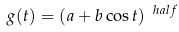<formula> <loc_0><loc_0><loc_500><loc_500>g ( t ) = ( a + b \cos t ) ^ { \ h a l f }</formula> 